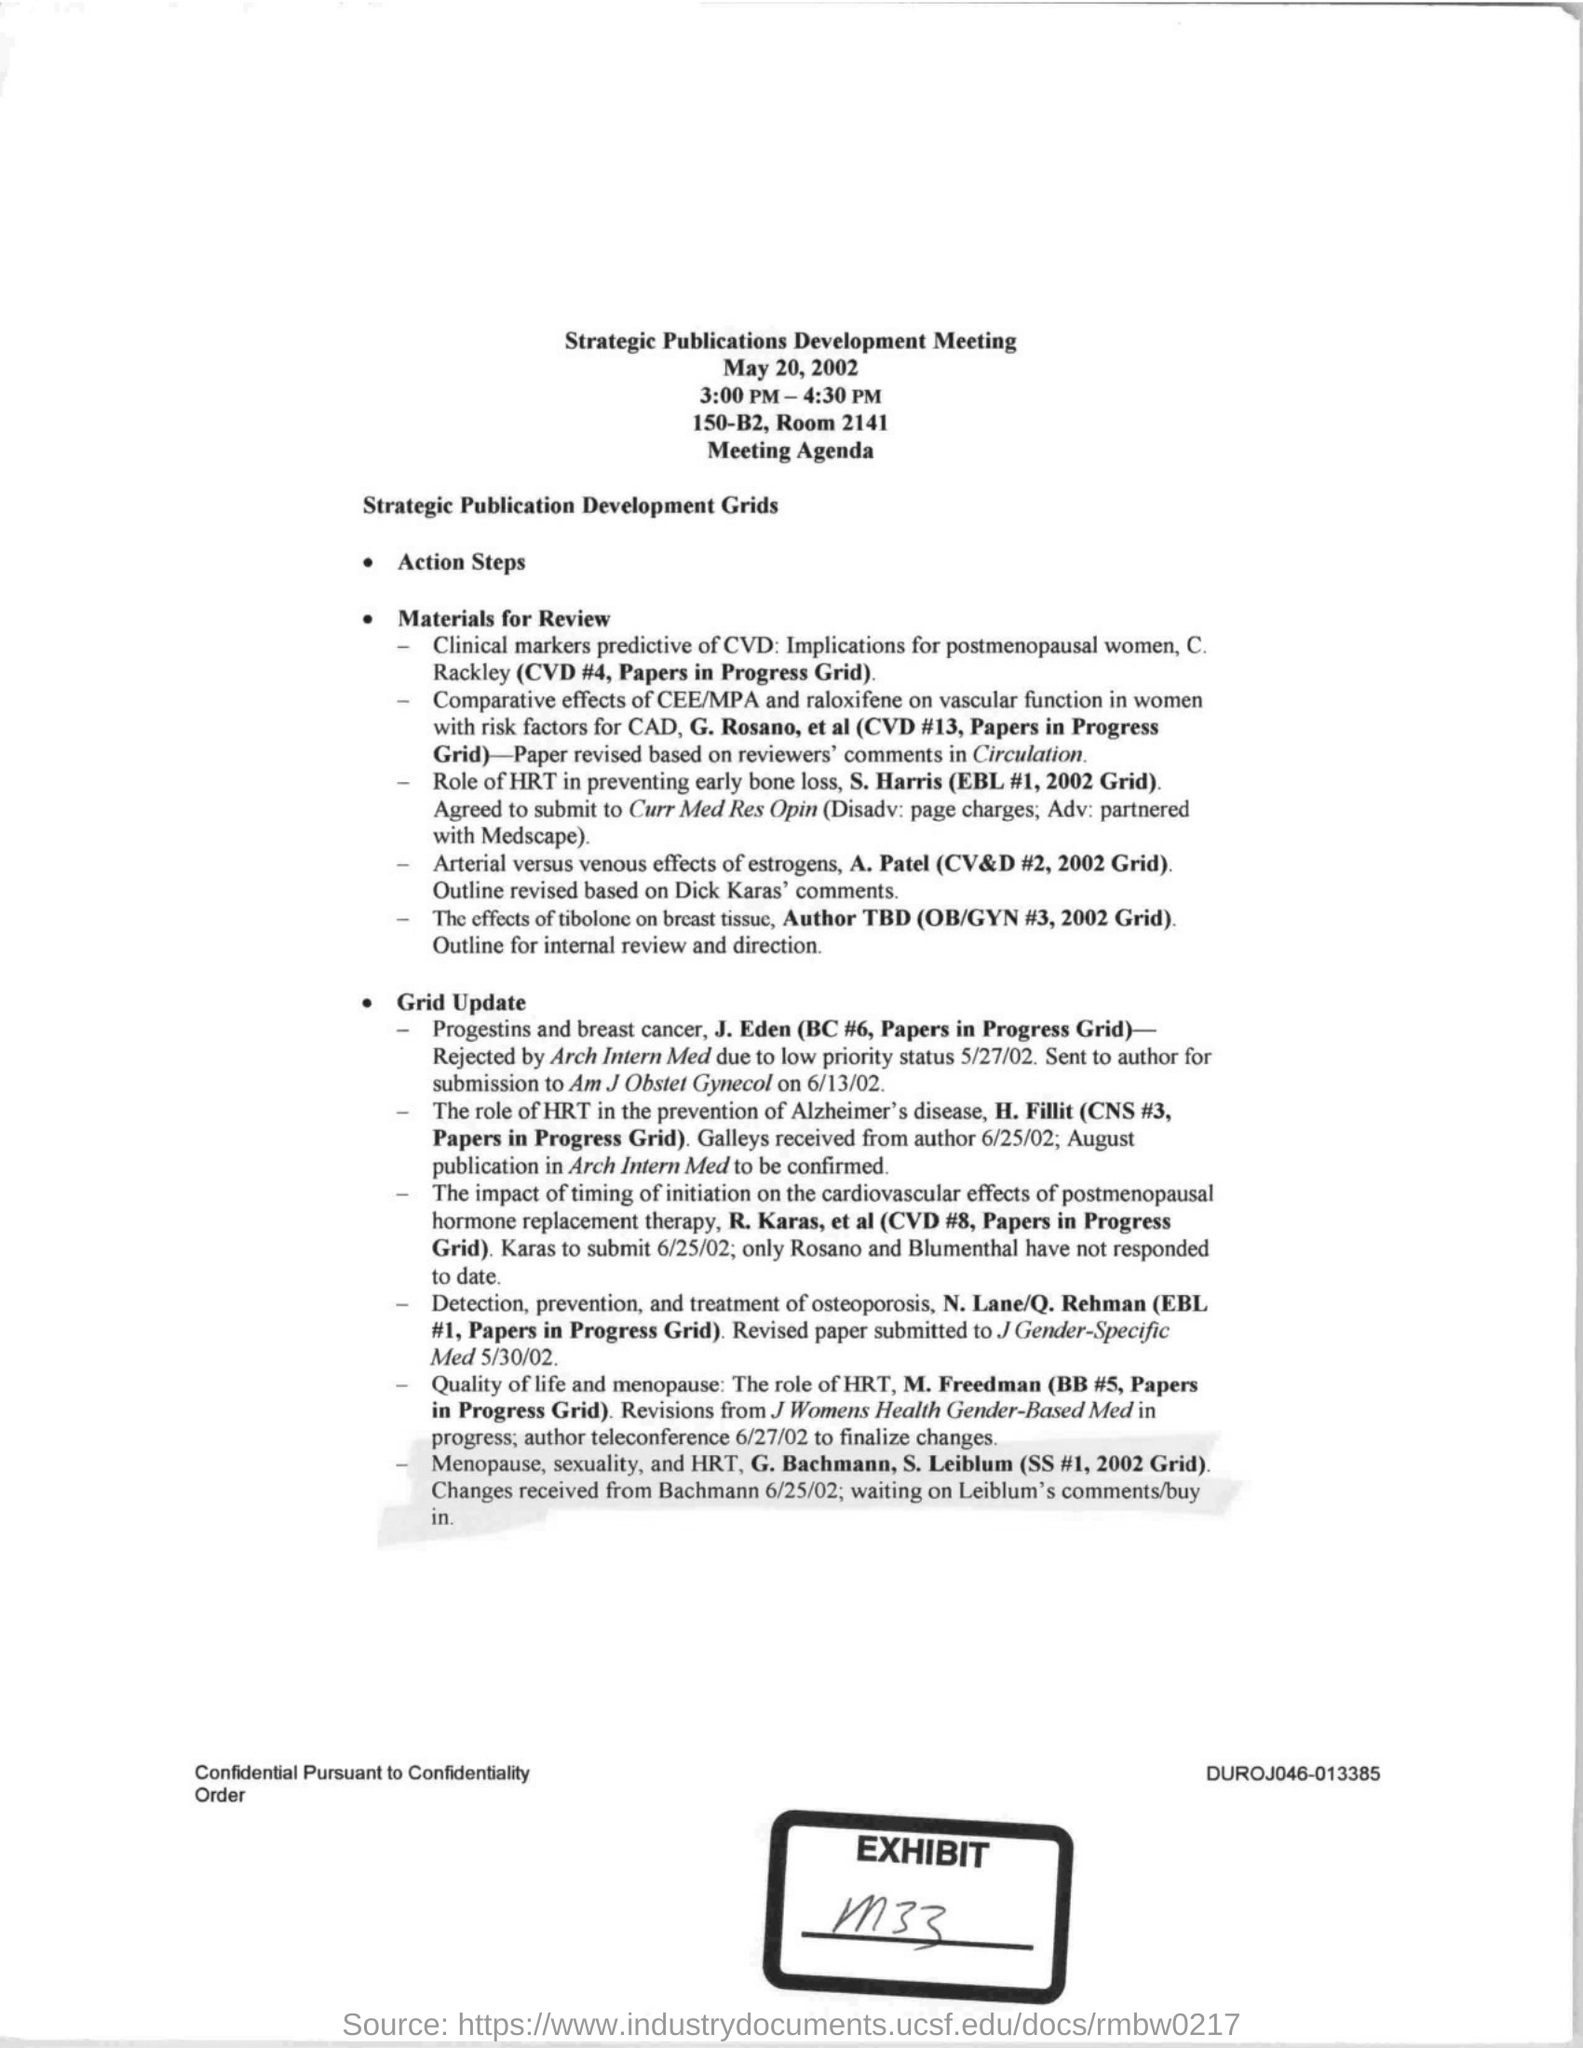Outline some significant characteristics in this image. The Strategic Publications Development Meeting will be held on May 20, 2002. The Strategic Publications Development Meeting is organized at 150-B2, Room 2141. The Strategic Publications Development Meeting is held from 3:00 PM to 4:30 PM. 